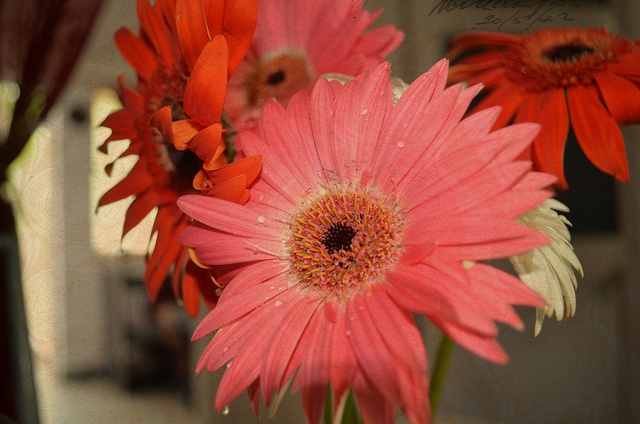Describe the objects in this image and their specific colors. I can see a chair in black, maroon, and gray tones in this image. 